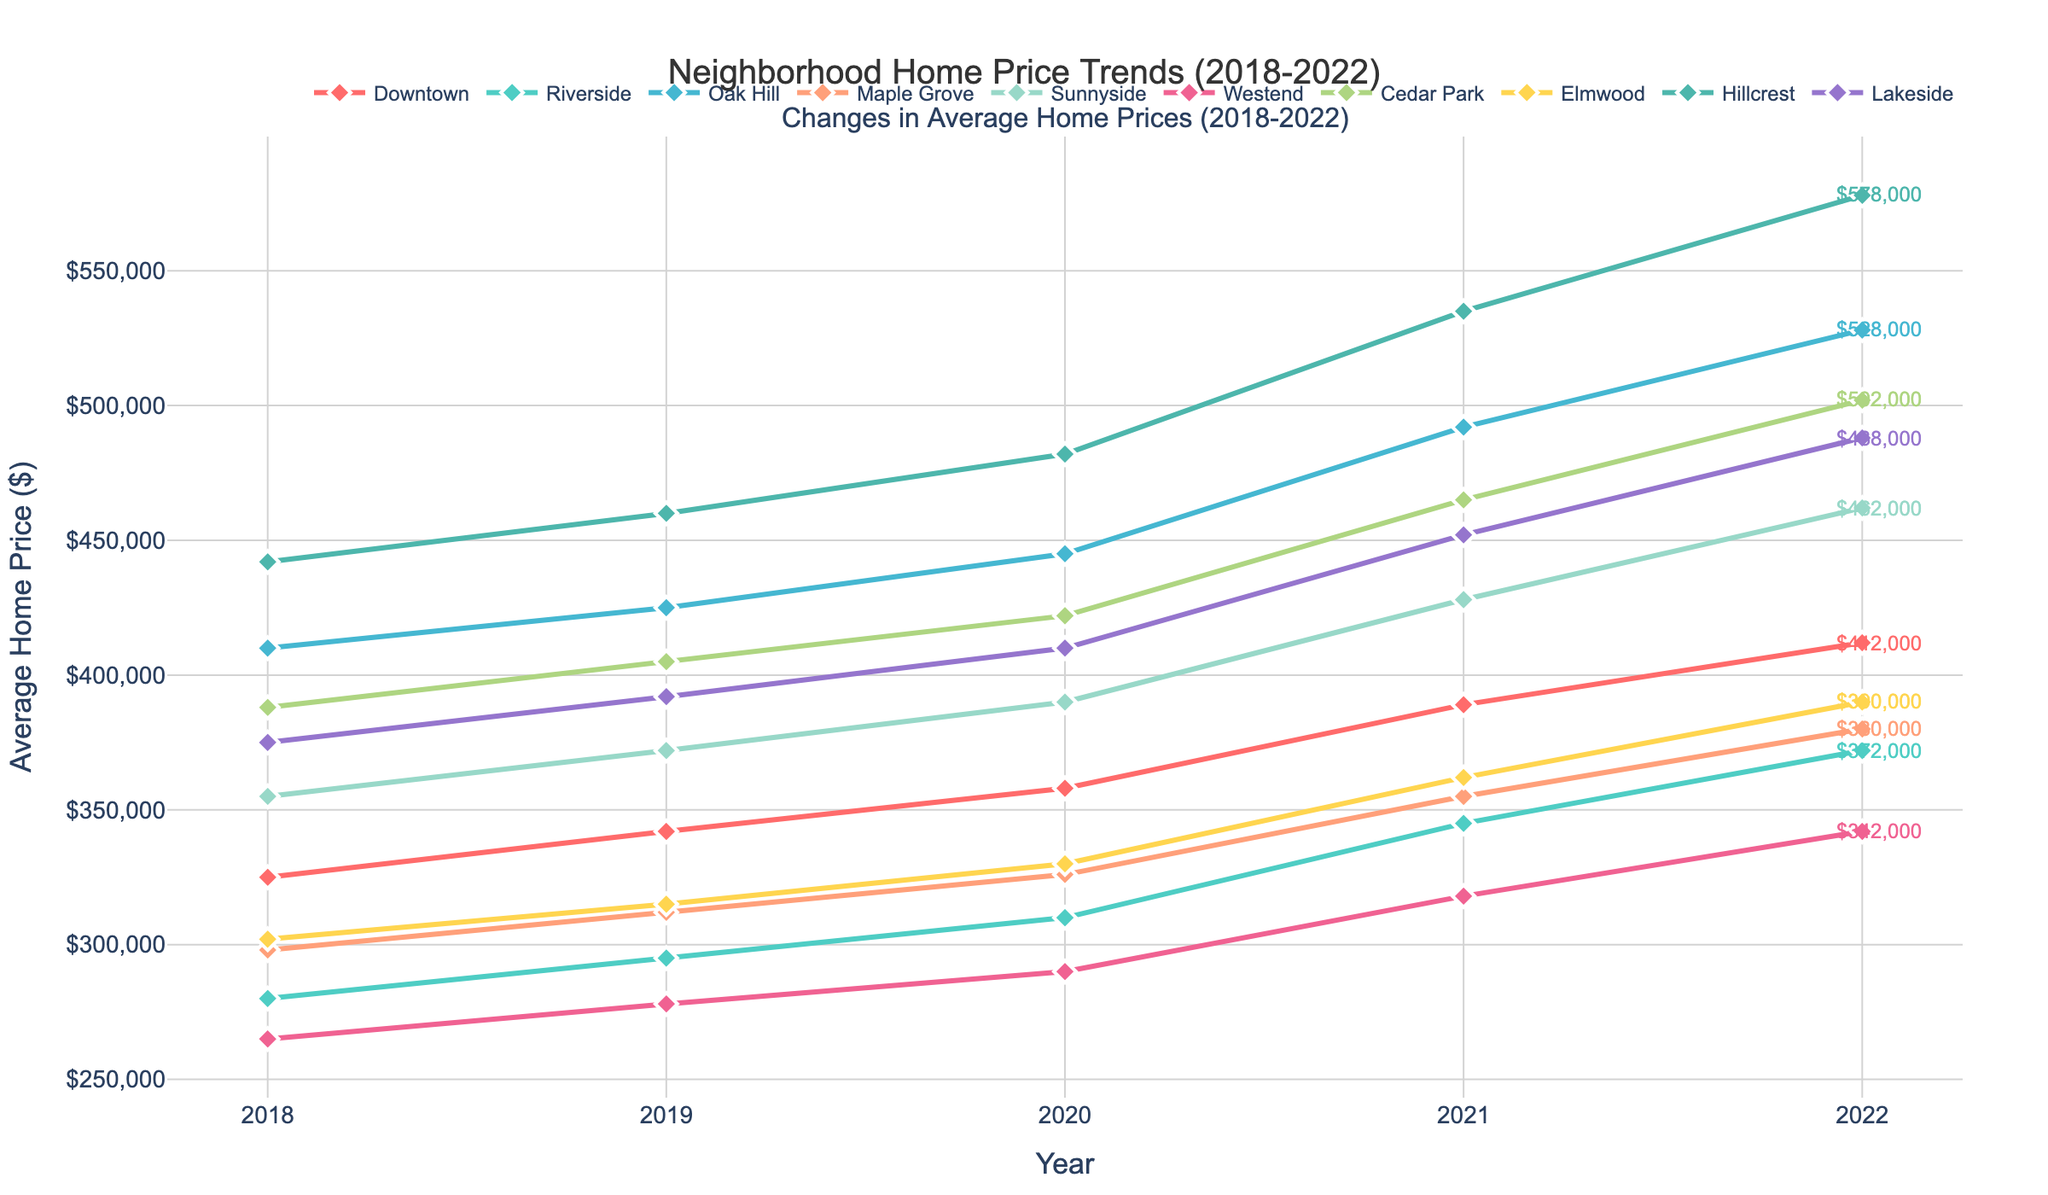What's the neighborhood with the highest average home price in 2022? Look for the line ending at the highest point in 2022 on the vertical scale.
Answer: Hillcrest What's the total increase in average home price from 2018 to 2022 for Sunnyside? Calculate the difference between the home prices in 2022 and 2018 for Sunnyside: 462000 - 355000 = 107000
Answer: 107000 Which neighborhood experienced the largest percentage increase in average home price from 2018 to 2022? Calculate the percentage increase for each neighborhood using the formula: ((Price_2022 - Price_2018) / Price_2018) * 100. Compare the results.
Answer: Hillcrest How does the average home price trend in Downtown compare to Riverside between 2020 and 2022? Examine the slope of the lines for Downtown and Riverside from 2020 to 2022. Downtown rises from 358000 to 412000; Riverside from 310000 to 372000. Both increased, but Downtown more steeply.
Answer: Downtown increased more steeply Considering all neighborhoods, which one had the smallest change in average home price from 2018 to 2022? Calculate the change for each neighborhood and compare them. Westend's change is 342000 - 265000 = 77000, this is the smallest.
Answer: Westend Which two neighborhoods had average home prices closest to each other in 2022? Compare the 2022 prices for all neighborhoods and find the smallest difference: Downtown (412000) and Lakeside (488000) have a difference of 76000.
Answer: Downtown and Lakeside What was the average home price in all neighborhoods in 2018? Add all prices for 2018 and divide by the number of neighborhoods: (325000 + 280000 + 410000 + 298000 + 355000 + 265000 + 388000 + 302000 + 442000 + 375000) / 10 = 3440000 / 10
Answer: 344000 Between Oak Hill and Maple Grove, which neighborhood had a higher average home price consistently throughout the years 2018-2022? Compare the yearly prices for both neighborhoods and observe if any year Oak Hill's price is not greater than Maple Grove's. Oak Hill consistently has a higher price.
Answer: Oak Hill 